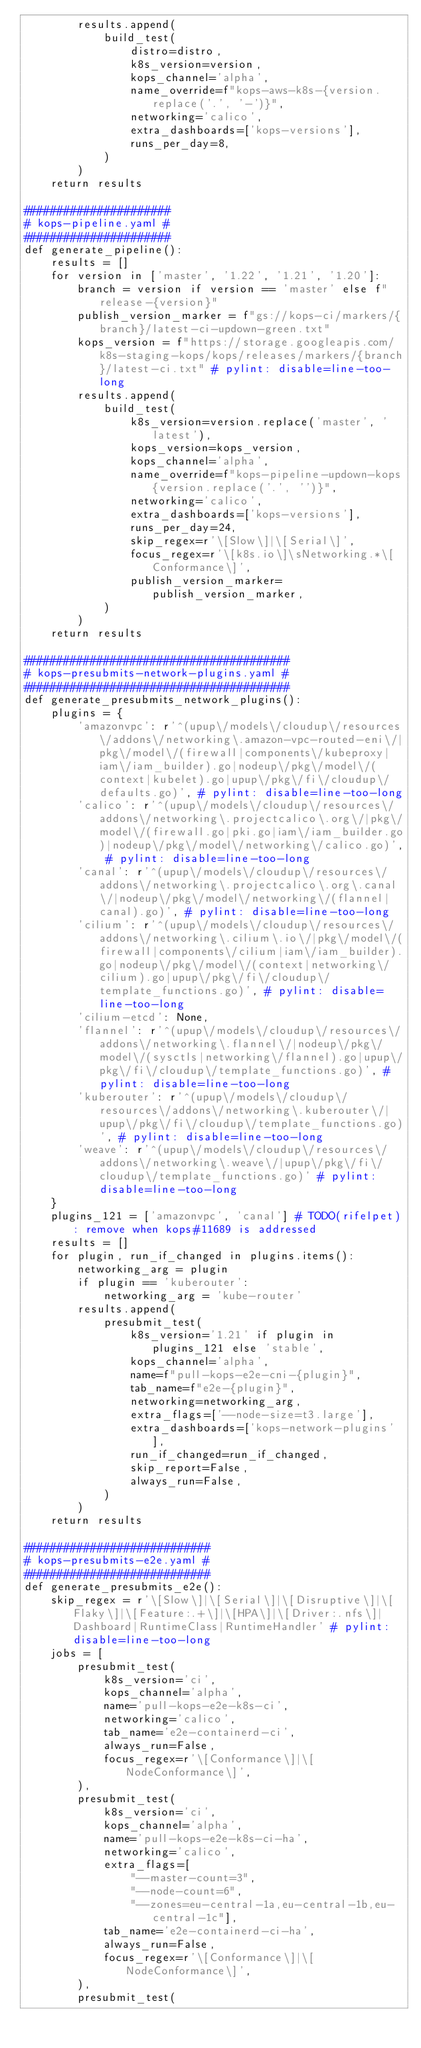Convert code to text. <code><loc_0><loc_0><loc_500><loc_500><_Python_>        results.append(
            build_test(
                distro=distro,
                k8s_version=version,
                kops_channel='alpha',
                name_override=f"kops-aws-k8s-{version.replace('.', '-')}",
                networking='calico',
                extra_dashboards=['kops-versions'],
                runs_per_day=8,
            )
        )
    return results

######################
# kops-pipeline.yaml #
######################
def generate_pipeline():
    results = []
    for version in ['master', '1.22', '1.21', '1.20']:
        branch = version if version == 'master' else f"release-{version}"
        publish_version_marker = f"gs://kops-ci/markers/{branch}/latest-ci-updown-green.txt"
        kops_version = f"https://storage.googleapis.com/k8s-staging-kops/kops/releases/markers/{branch}/latest-ci.txt" # pylint: disable=line-too-long
        results.append(
            build_test(
                k8s_version=version.replace('master', 'latest'),
                kops_version=kops_version,
                kops_channel='alpha',
                name_override=f"kops-pipeline-updown-kops{version.replace('.', '')}",
                networking='calico',
                extra_dashboards=['kops-versions'],
                runs_per_day=24,
                skip_regex=r'\[Slow\]|\[Serial\]',
                focus_regex=r'\[k8s.io\]\sNetworking.*\[Conformance\]',
                publish_version_marker=publish_version_marker,
            )
        )
    return results

########################################
# kops-presubmits-network-plugins.yaml #
########################################
def generate_presubmits_network_plugins():
    plugins = {
        'amazonvpc': r'^(upup\/models\/cloudup\/resources\/addons\/networking\.amazon-vpc-routed-eni\/|pkg\/model\/(firewall|components\/kubeproxy|iam\/iam_builder).go|nodeup\/pkg\/model\/(context|kubelet).go|upup\/pkg\/fi\/cloudup\/defaults.go)', # pylint: disable=line-too-long
        'calico': r'^(upup\/models\/cloudup\/resources\/addons\/networking\.projectcalico\.org\/|pkg\/model\/(firewall.go|pki.go|iam\/iam_builder.go)|nodeup\/pkg\/model\/networking\/calico.go)', # pylint: disable=line-too-long
        'canal': r'^(upup\/models\/cloudup\/resources\/addons\/networking\.projectcalico\.org\.canal\/|nodeup\/pkg\/model\/networking\/(flannel|canal).go)', # pylint: disable=line-too-long
        'cilium': r'^(upup\/models\/cloudup\/resources\/addons\/networking\.cilium\.io\/|pkg\/model\/(firewall|components\/cilium|iam\/iam_builder).go|nodeup\/pkg\/model\/(context|networking\/cilium).go|upup\/pkg\/fi\/cloudup\/template_functions.go)', # pylint: disable=line-too-long
        'cilium-etcd': None,
        'flannel': r'^(upup\/models\/cloudup\/resources\/addons\/networking\.flannel\/|nodeup\/pkg\/model\/(sysctls|networking\/flannel).go|upup\/pkg\/fi\/cloudup\/template_functions.go)', # pylint: disable=line-too-long
        'kuberouter': r'^(upup\/models\/cloudup\/resources\/addons\/networking\.kuberouter\/|upup\/pkg\/fi\/cloudup\/template_functions.go)', # pylint: disable=line-too-long
        'weave': r'^(upup\/models\/cloudup\/resources\/addons\/networking\.weave\/|upup\/pkg\/fi\/cloudup\/template_functions.go)' # pylint: disable=line-too-long
    }
    plugins_121 = ['amazonvpc', 'canal'] # TODO(rifelpet): remove when kops#11689 is addressed
    results = []
    for plugin, run_if_changed in plugins.items():
        networking_arg = plugin
        if plugin == 'kuberouter':
            networking_arg = 'kube-router'
        results.append(
            presubmit_test(
                k8s_version='1.21' if plugin in plugins_121 else 'stable',
                kops_channel='alpha',
                name=f"pull-kops-e2e-cni-{plugin}",
                tab_name=f"e2e-{plugin}",
                networking=networking_arg,
                extra_flags=['--node-size=t3.large'],
                extra_dashboards=['kops-network-plugins'],
                run_if_changed=run_if_changed,
                skip_report=False,
                always_run=False,
            )
        )
    return results

############################
# kops-presubmits-e2e.yaml #
############################
def generate_presubmits_e2e():
    skip_regex = r'\[Slow\]|\[Serial\]|\[Disruptive\]|\[Flaky\]|\[Feature:.+\]|\[HPA\]|\[Driver:.nfs\]|Dashboard|RuntimeClass|RuntimeHandler' # pylint: disable=line-too-long
    jobs = [
        presubmit_test(
            k8s_version='ci',
            kops_channel='alpha',
            name='pull-kops-e2e-k8s-ci',
            networking='calico',
            tab_name='e2e-containerd-ci',
            always_run=False,
            focus_regex=r'\[Conformance\]|\[NodeConformance\]',
        ),
        presubmit_test(
            k8s_version='ci',
            kops_channel='alpha',
            name='pull-kops-e2e-k8s-ci-ha',
            networking='calico',
            extra_flags=[
                "--master-count=3",
                "--node-count=6",
                "--zones=eu-central-1a,eu-central-1b,eu-central-1c"],
            tab_name='e2e-containerd-ci-ha',
            always_run=False,
            focus_regex=r'\[Conformance\]|\[NodeConformance\]',
        ),
        presubmit_test(</code> 